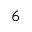Convert formula to latex. <formula><loc_0><loc_0><loc_500><loc_500>6</formula> 